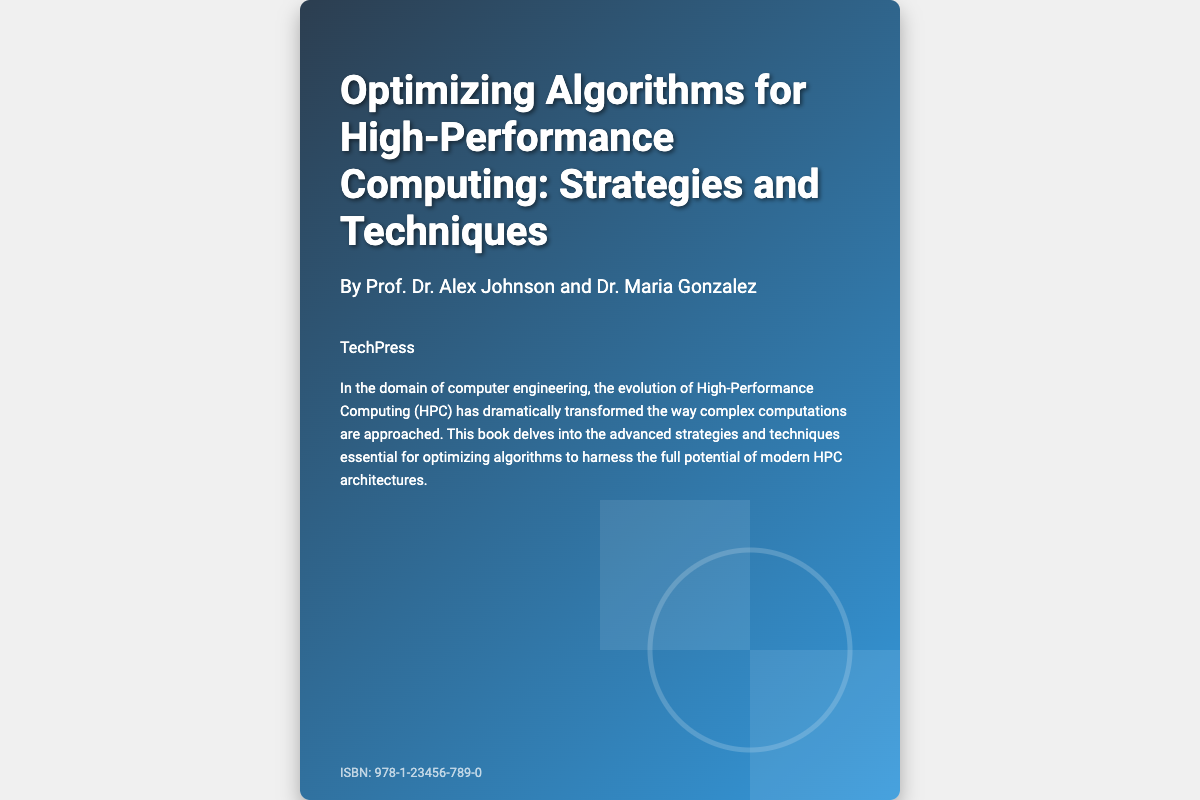What is the title of the book? The title of the book is explicitly stated on the cover.
Answer: Optimizing Algorithms for High-Performance Computing: Strategies and Techniques Who are the authors of the book? The authors are listed in the authors section of the cover.
Answer: Prof. Dr. Alex Johnson and Dr. Maria Gonzalez What is the name of the publisher? The publisher's name is provided in the publisher section of the cover.
Answer: TechPress What is the ISBN number? The ISBN number is mentioned at the bottom of the cover.
Answer: 978-1-23456-789-0 What main topic does the book focus on? The synopsis outlines the main subject matter of the book.
Answer: Optimizing algorithms What is the main goal of the book? The synopsis indicates the purpose of the book regarding HPC.
Answer: Harness the full potential of modern HPC architectures What design style is used for the book cover? The style of the cover can be discerned from its visual elements.
Answer: Linear gradient What type of computing does the book discuss? The synopsis makes it clear that the book is about a specific type of computing.
Answer: High-Performance Computing (HPC) How significant is the evolution of HPC according to the synopsis? The synopsis suggests the transformative nature of HPC in computations.
Answer: Dramatically transformed 